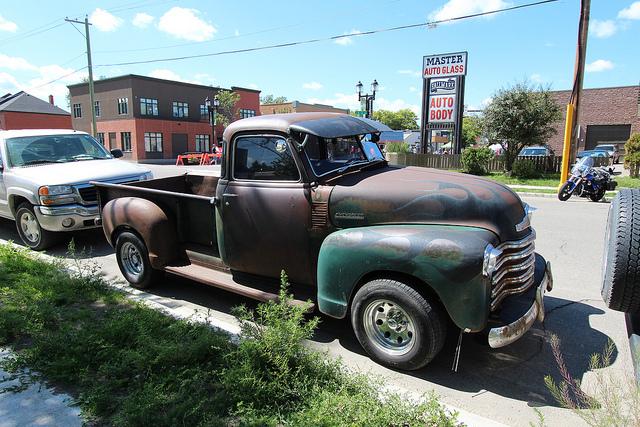Do you see a brand new truck?
Short answer required. No. How many cars are there?
Quick response, please. 2. Is there rust on the truck?
Quick response, please. Yes. 